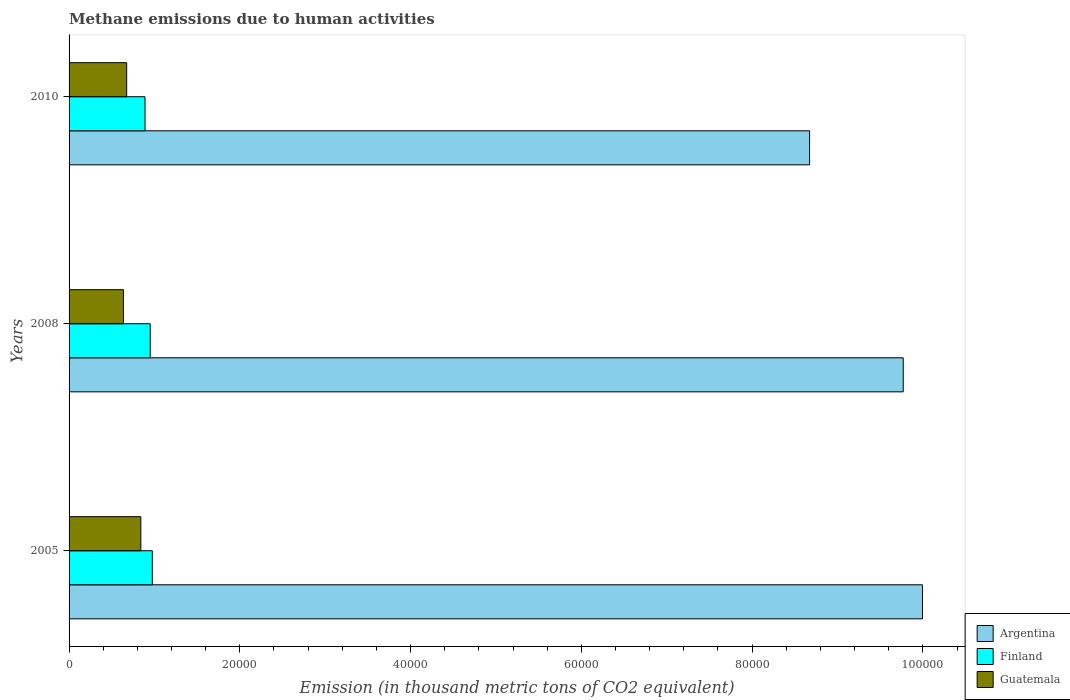How many different coloured bars are there?
Offer a terse response. 3. How many bars are there on the 1st tick from the top?
Your answer should be very brief. 3. How many bars are there on the 2nd tick from the bottom?
Make the answer very short. 3. In how many cases, is the number of bars for a given year not equal to the number of legend labels?
Provide a succinct answer. 0. What is the amount of methane emitted in Argentina in 2005?
Offer a very short reply. 1.00e+05. Across all years, what is the maximum amount of methane emitted in Guatemala?
Give a very brief answer. 8404.9. Across all years, what is the minimum amount of methane emitted in Guatemala?
Give a very brief answer. 6365.4. What is the total amount of methane emitted in Finland in the graph?
Offer a terse response. 2.82e+04. What is the difference between the amount of methane emitted in Argentina in 2005 and that in 2008?
Your response must be concise. 2253.8. What is the difference between the amount of methane emitted in Guatemala in 2005 and the amount of methane emitted in Argentina in 2008?
Offer a terse response. -8.93e+04. What is the average amount of methane emitted in Argentina per year?
Your response must be concise. 9.48e+04. In the year 2010, what is the difference between the amount of methane emitted in Guatemala and amount of methane emitted in Finland?
Ensure brevity in your answer.  -2149.8. In how many years, is the amount of methane emitted in Guatemala greater than 40000 thousand metric tons?
Your answer should be very brief. 0. What is the ratio of the amount of methane emitted in Guatemala in 2005 to that in 2008?
Give a very brief answer. 1.32. Is the amount of methane emitted in Finland in 2005 less than that in 2008?
Give a very brief answer. No. What is the difference between the highest and the second highest amount of methane emitted in Argentina?
Give a very brief answer. 2253.8. What is the difference between the highest and the lowest amount of methane emitted in Guatemala?
Provide a succinct answer. 2039.5. Is the sum of the amount of methane emitted in Argentina in 2008 and 2010 greater than the maximum amount of methane emitted in Finland across all years?
Your response must be concise. Yes. How many bars are there?
Keep it short and to the point. 9. How many years are there in the graph?
Provide a short and direct response. 3. What is the difference between two consecutive major ticks on the X-axis?
Provide a succinct answer. 2.00e+04. Are the values on the major ticks of X-axis written in scientific E-notation?
Ensure brevity in your answer.  No. Where does the legend appear in the graph?
Provide a short and direct response. Bottom right. What is the title of the graph?
Your answer should be very brief. Methane emissions due to human activities. Does "Finland" appear as one of the legend labels in the graph?
Ensure brevity in your answer.  Yes. What is the label or title of the X-axis?
Give a very brief answer. Emission (in thousand metric tons of CO2 equivalent). What is the label or title of the Y-axis?
Ensure brevity in your answer.  Years. What is the Emission (in thousand metric tons of CO2 equivalent) in Argentina in 2005?
Offer a very short reply. 1.00e+05. What is the Emission (in thousand metric tons of CO2 equivalent) of Finland in 2005?
Provide a succinct answer. 9750. What is the Emission (in thousand metric tons of CO2 equivalent) in Guatemala in 2005?
Your response must be concise. 8404.9. What is the Emission (in thousand metric tons of CO2 equivalent) of Argentina in 2008?
Your answer should be very brief. 9.77e+04. What is the Emission (in thousand metric tons of CO2 equivalent) in Finland in 2008?
Make the answer very short. 9506.7. What is the Emission (in thousand metric tons of CO2 equivalent) of Guatemala in 2008?
Your answer should be compact. 6365.4. What is the Emission (in thousand metric tons of CO2 equivalent) in Argentina in 2010?
Keep it short and to the point. 8.67e+04. What is the Emission (in thousand metric tons of CO2 equivalent) in Finland in 2010?
Provide a short and direct response. 8895.5. What is the Emission (in thousand metric tons of CO2 equivalent) of Guatemala in 2010?
Your answer should be compact. 6745.7. Across all years, what is the maximum Emission (in thousand metric tons of CO2 equivalent) in Argentina?
Your answer should be very brief. 1.00e+05. Across all years, what is the maximum Emission (in thousand metric tons of CO2 equivalent) of Finland?
Your response must be concise. 9750. Across all years, what is the maximum Emission (in thousand metric tons of CO2 equivalent) of Guatemala?
Your response must be concise. 8404.9. Across all years, what is the minimum Emission (in thousand metric tons of CO2 equivalent) of Argentina?
Make the answer very short. 8.67e+04. Across all years, what is the minimum Emission (in thousand metric tons of CO2 equivalent) in Finland?
Offer a very short reply. 8895.5. Across all years, what is the minimum Emission (in thousand metric tons of CO2 equivalent) of Guatemala?
Keep it short and to the point. 6365.4. What is the total Emission (in thousand metric tons of CO2 equivalent) of Argentina in the graph?
Make the answer very short. 2.84e+05. What is the total Emission (in thousand metric tons of CO2 equivalent) in Finland in the graph?
Offer a terse response. 2.82e+04. What is the total Emission (in thousand metric tons of CO2 equivalent) in Guatemala in the graph?
Offer a terse response. 2.15e+04. What is the difference between the Emission (in thousand metric tons of CO2 equivalent) of Argentina in 2005 and that in 2008?
Offer a very short reply. 2253.8. What is the difference between the Emission (in thousand metric tons of CO2 equivalent) of Finland in 2005 and that in 2008?
Give a very brief answer. 243.3. What is the difference between the Emission (in thousand metric tons of CO2 equivalent) in Guatemala in 2005 and that in 2008?
Offer a very short reply. 2039.5. What is the difference between the Emission (in thousand metric tons of CO2 equivalent) in Argentina in 2005 and that in 2010?
Ensure brevity in your answer.  1.32e+04. What is the difference between the Emission (in thousand metric tons of CO2 equivalent) of Finland in 2005 and that in 2010?
Offer a terse response. 854.5. What is the difference between the Emission (in thousand metric tons of CO2 equivalent) of Guatemala in 2005 and that in 2010?
Provide a succinct answer. 1659.2. What is the difference between the Emission (in thousand metric tons of CO2 equivalent) of Argentina in 2008 and that in 2010?
Your response must be concise. 1.10e+04. What is the difference between the Emission (in thousand metric tons of CO2 equivalent) of Finland in 2008 and that in 2010?
Offer a terse response. 611.2. What is the difference between the Emission (in thousand metric tons of CO2 equivalent) in Guatemala in 2008 and that in 2010?
Your answer should be compact. -380.3. What is the difference between the Emission (in thousand metric tons of CO2 equivalent) of Argentina in 2005 and the Emission (in thousand metric tons of CO2 equivalent) of Finland in 2008?
Your answer should be compact. 9.04e+04. What is the difference between the Emission (in thousand metric tons of CO2 equivalent) in Argentina in 2005 and the Emission (in thousand metric tons of CO2 equivalent) in Guatemala in 2008?
Keep it short and to the point. 9.36e+04. What is the difference between the Emission (in thousand metric tons of CO2 equivalent) of Finland in 2005 and the Emission (in thousand metric tons of CO2 equivalent) of Guatemala in 2008?
Make the answer very short. 3384.6. What is the difference between the Emission (in thousand metric tons of CO2 equivalent) in Argentina in 2005 and the Emission (in thousand metric tons of CO2 equivalent) in Finland in 2010?
Give a very brief answer. 9.11e+04. What is the difference between the Emission (in thousand metric tons of CO2 equivalent) in Argentina in 2005 and the Emission (in thousand metric tons of CO2 equivalent) in Guatemala in 2010?
Ensure brevity in your answer.  9.32e+04. What is the difference between the Emission (in thousand metric tons of CO2 equivalent) of Finland in 2005 and the Emission (in thousand metric tons of CO2 equivalent) of Guatemala in 2010?
Your answer should be very brief. 3004.3. What is the difference between the Emission (in thousand metric tons of CO2 equivalent) in Argentina in 2008 and the Emission (in thousand metric tons of CO2 equivalent) in Finland in 2010?
Offer a terse response. 8.88e+04. What is the difference between the Emission (in thousand metric tons of CO2 equivalent) of Argentina in 2008 and the Emission (in thousand metric tons of CO2 equivalent) of Guatemala in 2010?
Offer a terse response. 9.10e+04. What is the difference between the Emission (in thousand metric tons of CO2 equivalent) of Finland in 2008 and the Emission (in thousand metric tons of CO2 equivalent) of Guatemala in 2010?
Offer a terse response. 2761. What is the average Emission (in thousand metric tons of CO2 equivalent) of Argentina per year?
Your answer should be compact. 9.48e+04. What is the average Emission (in thousand metric tons of CO2 equivalent) of Finland per year?
Provide a succinct answer. 9384.07. What is the average Emission (in thousand metric tons of CO2 equivalent) of Guatemala per year?
Offer a terse response. 7172. In the year 2005, what is the difference between the Emission (in thousand metric tons of CO2 equivalent) of Argentina and Emission (in thousand metric tons of CO2 equivalent) of Finland?
Offer a very short reply. 9.02e+04. In the year 2005, what is the difference between the Emission (in thousand metric tons of CO2 equivalent) in Argentina and Emission (in thousand metric tons of CO2 equivalent) in Guatemala?
Your response must be concise. 9.16e+04. In the year 2005, what is the difference between the Emission (in thousand metric tons of CO2 equivalent) in Finland and Emission (in thousand metric tons of CO2 equivalent) in Guatemala?
Keep it short and to the point. 1345.1. In the year 2008, what is the difference between the Emission (in thousand metric tons of CO2 equivalent) of Argentina and Emission (in thousand metric tons of CO2 equivalent) of Finland?
Keep it short and to the point. 8.82e+04. In the year 2008, what is the difference between the Emission (in thousand metric tons of CO2 equivalent) of Argentina and Emission (in thousand metric tons of CO2 equivalent) of Guatemala?
Provide a short and direct response. 9.13e+04. In the year 2008, what is the difference between the Emission (in thousand metric tons of CO2 equivalent) in Finland and Emission (in thousand metric tons of CO2 equivalent) in Guatemala?
Your answer should be very brief. 3141.3. In the year 2010, what is the difference between the Emission (in thousand metric tons of CO2 equivalent) of Argentina and Emission (in thousand metric tons of CO2 equivalent) of Finland?
Provide a succinct answer. 7.78e+04. In the year 2010, what is the difference between the Emission (in thousand metric tons of CO2 equivalent) of Argentina and Emission (in thousand metric tons of CO2 equivalent) of Guatemala?
Keep it short and to the point. 8.00e+04. In the year 2010, what is the difference between the Emission (in thousand metric tons of CO2 equivalent) in Finland and Emission (in thousand metric tons of CO2 equivalent) in Guatemala?
Your response must be concise. 2149.8. What is the ratio of the Emission (in thousand metric tons of CO2 equivalent) in Argentina in 2005 to that in 2008?
Provide a succinct answer. 1.02. What is the ratio of the Emission (in thousand metric tons of CO2 equivalent) of Finland in 2005 to that in 2008?
Offer a very short reply. 1.03. What is the ratio of the Emission (in thousand metric tons of CO2 equivalent) in Guatemala in 2005 to that in 2008?
Keep it short and to the point. 1.32. What is the ratio of the Emission (in thousand metric tons of CO2 equivalent) in Argentina in 2005 to that in 2010?
Provide a short and direct response. 1.15. What is the ratio of the Emission (in thousand metric tons of CO2 equivalent) in Finland in 2005 to that in 2010?
Keep it short and to the point. 1.1. What is the ratio of the Emission (in thousand metric tons of CO2 equivalent) of Guatemala in 2005 to that in 2010?
Keep it short and to the point. 1.25. What is the ratio of the Emission (in thousand metric tons of CO2 equivalent) of Argentina in 2008 to that in 2010?
Ensure brevity in your answer.  1.13. What is the ratio of the Emission (in thousand metric tons of CO2 equivalent) of Finland in 2008 to that in 2010?
Keep it short and to the point. 1.07. What is the ratio of the Emission (in thousand metric tons of CO2 equivalent) in Guatemala in 2008 to that in 2010?
Offer a terse response. 0.94. What is the difference between the highest and the second highest Emission (in thousand metric tons of CO2 equivalent) of Argentina?
Provide a succinct answer. 2253.8. What is the difference between the highest and the second highest Emission (in thousand metric tons of CO2 equivalent) in Finland?
Your answer should be compact. 243.3. What is the difference between the highest and the second highest Emission (in thousand metric tons of CO2 equivalent) of Guatemala?
Offer a terse response. 1659.2. What is the difference between the highest and the lowest Emission (in thousand metric tons of CO2 equivalent) of Argentina?
Make the answer very short. 1.32e+04. What is the difference between the highest and the lowest Emission (in thousand metric tons of CO2 equivalent) of Finland?
Your answer should be very brief. 854.5. What is the difference between the highest and the lowest Emission (in thousand metric tons of CO2 equivalent) in Guatemala?
Make the answer very short. 2039.5. 